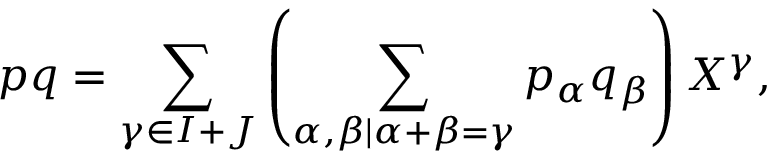Convert formula to latex. <formula><loc_0><loc_0><loc_500><loc_500>p q = \sum _ { \gamma \in I + J } \left ( \sum _ { \alpha , \beta | \alpha + \beta = \gamma } p _ { \alpha } q _ { \beta } \right ) X ^ { \gamma } ,</formula> 